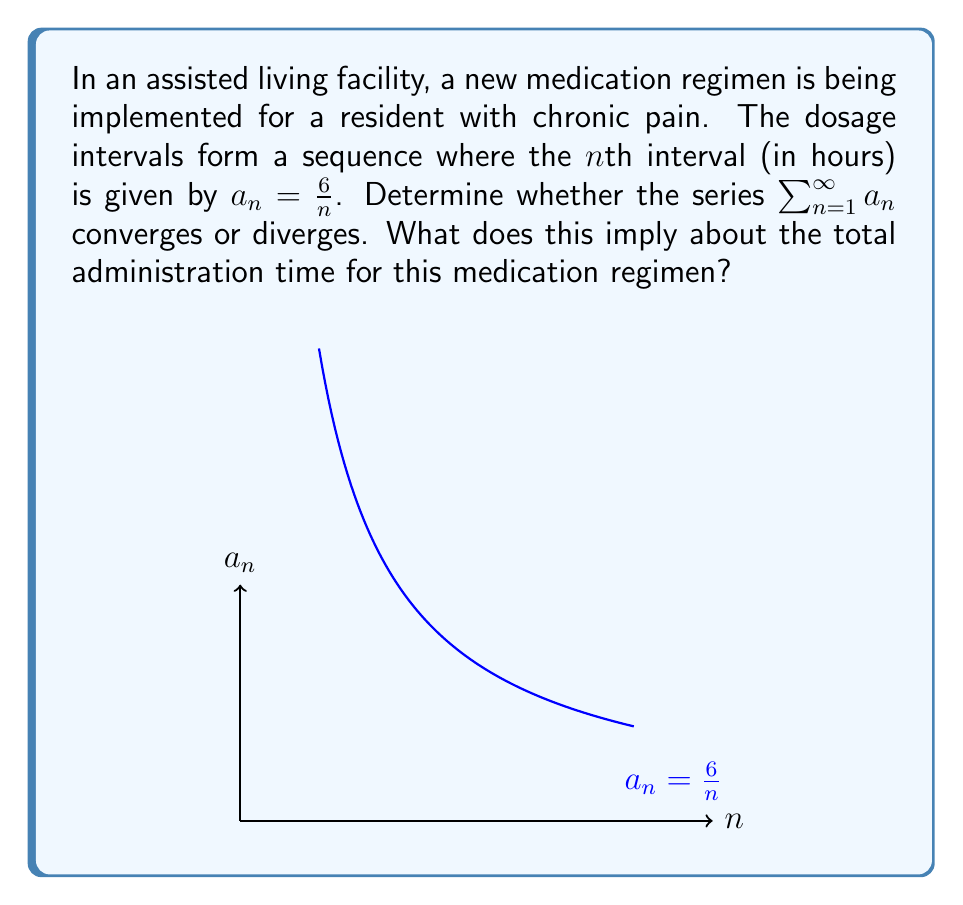What is the answer to this math problem? Let's approach this step-by-step:

1) We are dealing with the series $\sum_{n=1}^{\infty} a_n$ where $a_n = \frac{6}{n}$.

2) To determine convergence, we can use the p-series test. A p-series is of the form $\sum_{n=1}^{\infty} \frac{1}{n^p}$.

3) In our case, we can rewrite the series as:

   $\sum_{n=1}^{\infty} a_n = \sum_{n=1}^{\infty} \frac{6}{n} = 6 \sum_{n=1}^{\infty} \frac{1}{n}$

4) This is a p-series with $p = 1$.

5) For a p-series:
   - If $p > 1$, the series converges.
   - If $p \leq 1$, the series diverges.

6) In our case, $p = 1$, so the series diverges.

7) The divergence of this series implies that the sum of all dosage intervals is infinite.

8) In the context of medication administration, this means that if we were to sum up all the time intervals between doses, it would result in an infinite amount of time.
Answer: The series diverges, implying an infinite total administration time. 